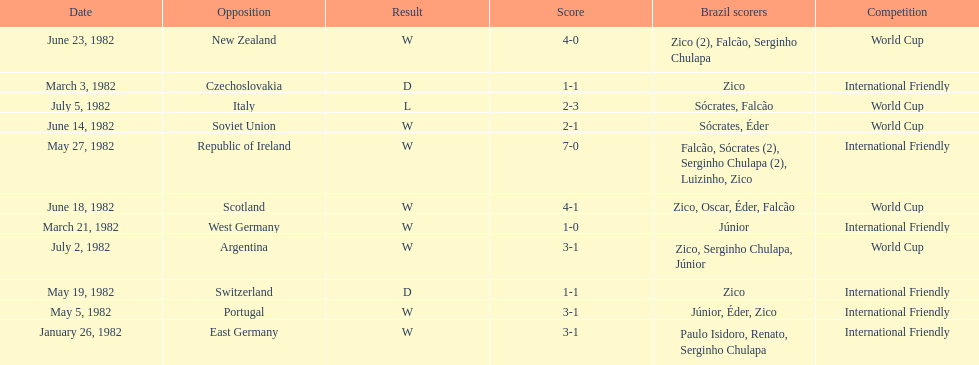What was the total number of losses brazil suffered? 1. 